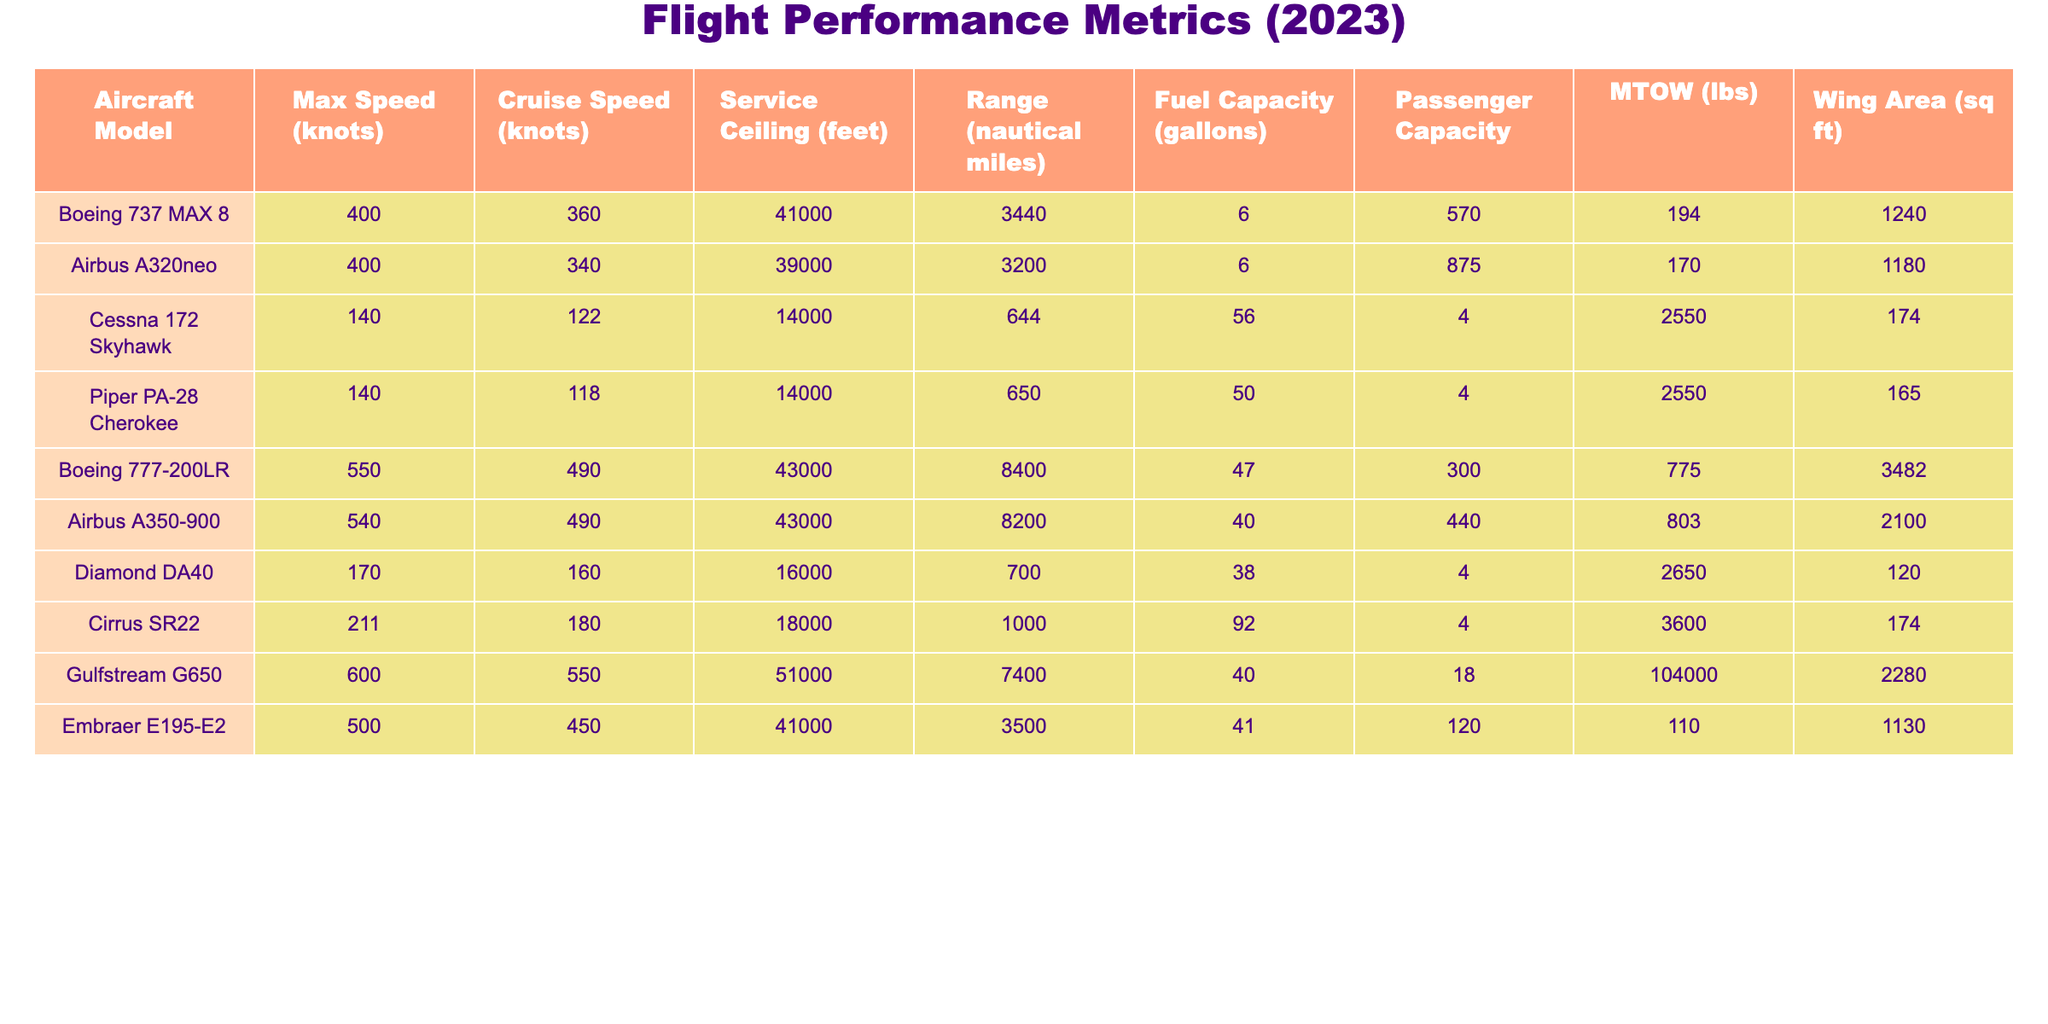What is the maximum speed of the Boeing 777-200LR? The table lists the maximum speed for the Boeing 777-200LR as 550 knots.
Answer: 550 knots What is the range of the Airbus A320neo? The range of the Airbus A320neo is given as 3200 nautical miles in the table.
Answer: 3200 nautical miles Which aircraft model has the highest service ceiling? Comparing the service ceiling values, the Gulfstream G650 has the highest service ceiling at 51,000 feet.
Answer: Gulfstream G650 What is the total passenger capacity of the Cessna 172 Skyhawk and Piper PA-28 Cherokee combined? The passenger capacity of the Cessna 172 Skyhawk is 4 and the Piper PA-28 Cherokee is also 4. Adding these together gives 4 + 4 = 8.
Answer: 8 Is the maximum takeoff weight (MTOW) of the Airbus A350-900 greater than that of the Boeing 777-200LR? The MTOW for the Airbus A350-900 is 803,000 lbs, while the MTOW for the Boeing 777-200LR is 775,000 lbs, making the Airbus A350-900 greater.
Answer: Yes What is the average range of all the aircraft listed in the table? The ranges of the aircraft are 3440, 3200, 644, 650, 8400, 8200, 700, 1000, 7400, and 3500. Summing these values gives 3440 + 3200 + 644 + 650 + 8400 + 8200 + 700 + 1000 + 7400 + 3500 = 28634. To find the average, divide by 10 total aircraft which equals 2863.4.
Answer: 2863.4 nautical miles What aircraft has a maximum speed closest to 400 knots? Looking at the max speeds in the table, the Airbus A320neo at 400 knots and the Boeing 737 MAX 8 at 400 knots have the exact value. Thus, both are closest to 400 knots.
Answer: Airbus A320neo and Boeing 737 MAX 8 Which aircraft model has the lowest wing area? The Wing area of each aircraft can be compared, and the Diamond DA40 has the lowest at 120 sq ft.
Answer: Diamond DA40 How many aircraft models have a service ceiling above 40,000 feet? By examining the table, the Gulfstream G650, Boeing 777-200LR, Airbus A350-900, and Embraer E195-E2 all have service ceilings above 40,000 feet, totaling 4 models.
Answer: 4 Is the fuel capacity of the Cessna 172 Skyhawk greater than the Cirrus SR22? The fuel capacity for the Cessna 172 Skyhawk is 56 gallons, while for the Cirrus SR22 it is 92 gallons. Therefore, the Cessna 172 Skyhawk’s fuel capacity is not greater.
Answer: No What is the difference in passenger capacity between the Boeing 777-200LR and the Gulfstream G650? The Boeing 777-200LR has a passenger capacity of 300 and the Gulfstream G650 has a capacity of 18. The difference is 300 - 18 = 282.
Answer: 282 passengers 